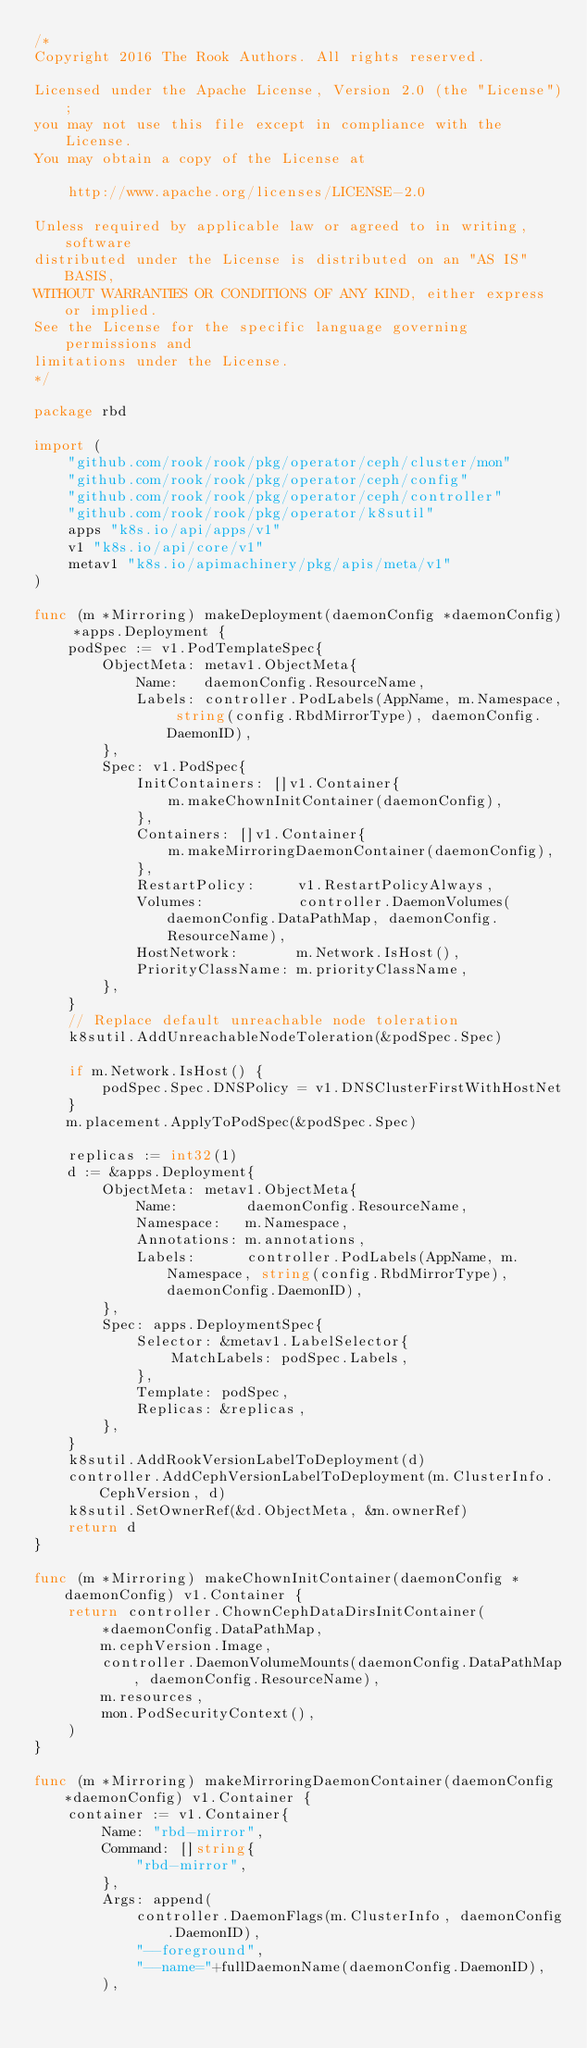<code> <loc_0><loc_0><loc_500><loc_500><_Go_>/*
Copyright 2016 The Rook Authors. All rights reserved.

Licensed under the Apache License, Version 2.0 (the "License");
you may not use this file except in compliance with the License.
You may obtain a copy of the License at

	http://www.apache.org/licenses/LICENSE-2.0

Unless required by applicable law or agreed to in writing, software
distributed under the License is distributed on an "AS IS" BASIS,
WITHOUT WARRANTIES OR CONDITIONS OF ANY KIND, either express or implied.
See the License for the specific language governing permissions and
limitations under the License.
*/

package rbd

import (
	"github.com/rook/rook/pkg/operator/ceph/cluster/mon"
	"github.com/rook/rook/pkg/operator/ceph/config"
	"github.com/rook/rook/pkg/operator/ceph/controller"
	"github.com/rook/rook/pkg/operator/k8sutil"
	apps "k8s.io/api/apps/v1"
	v1 "k8s.io/api/core/v1"
	metav1 "k8s.io/apimachinery/pkg/apis/meta/v1"
)

func (m *Mirroring) makeDeployment(daemonConfig *daemonConfig) *apps.Deployment {
	podSpec := v1.PodTemplateSpec{
		ObjectMeta: metav1.ObjectMeta{
			Name:   daemonConfig.ResourceName,
			Labels: controller.PodLabels(AppName, m.Namespace, string(config.RbdMirrorType), daemonConfig.DaemonID),
		},
		Spec: v1.PodSpec{
			InitContainers: []v1.Container{
				m.makeChownInitContainer(daemonConfig),
			},
			Containers: []v1.Container{
				m.makeMirroringDaemonContainer(daemonConfig),
			},
			RestartPolicy:     v1.RestartPolicyAlways,
			Volumes:           controller.DaemonVolumes(daemonConfig.DataPathMap, daemonConfig.ResourceName),
			HostNetwork:       m.Network.IsHost(),
			PriorityClassName: m.priorityClassName,
		},
	}
	// Replace default unreachable node toleration
	k8sutil.AddUnreachableNodeToleration(&podSpec.Spec)

	if m.Network.IsHost() {
		podSpec.Spec.DNSPolicy = v1.DNSClusterFirstWithHostNet
	}
	m.placement.ApplyToPodSpec(&podSpec.Spec)

	replicas := int32(1)
	d := &apps.Deployment{
		ObjectMeta: metav1.ObjectMeta{
			Name:        daemonConfig.ResourceName,
			Namespace:   m.Namespace,
			Annotations: m.annotations,
			Labels:      controller.PodLabels(AppName, m.Namespace, string(config.RbdMirrorType), daemonConfig.DaemonID),
		},
		Spec: apps.DeploymentSpec{
			Selector: &metav1.LabelSelector{
				MatchLabels: podSpec.Labels,
			},
			Template: podSpec,
			Replicas: &replicas,
		},
	}
	k8sutil.AddRookVersionLabelToDeployment(d)
	controller.AddCephVersionLabelToDeployment(m.ClusterInfo.CephVersion, d)
	k8sutil.SetOwnerRef(&d.ObjectMeta, &m.ownerRef)
	return d
}

func (m *Mirroring) makeChownInitContainer(daemonConfig *daemonConfig) v1.Container {
	return controller.ChownCephDataDirsInitContainer(
		*daemonConfig.DataPathMap,
		m.cephVersion.Image,
		controller.DaemonVolumeMounts(daemonConfig.DataPathMap, daemonConfig.ResourceName),
		m.resources,
		mon.PodSecurityContext(),
	)
}

func (m *Mirroring) makeMirroringDaemonContainer(daemonConfig *daemonConfig) v1.Container {
	container := v1.Container{
		Name: "rbd-mirror",
		Command: []string{
			"rbd-mirror",
		},
		Args: append(
			controller.DaemonFlags(m.ClusterInfo, daemonConfig.DaemonID),
			"--foreground",
			"--name="+fullDaemonName(daemonConfig.DaemonID),
		),</code> 